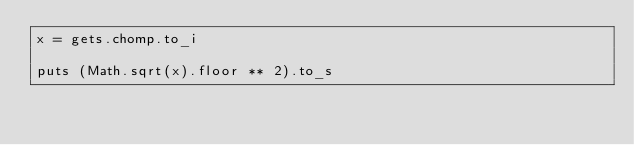Convert code to text. <code><loc_0><loc_0><loc_500><loc_500><_Ruby_>x = gets.chomp.to_i

puts (Math.sqrt(x).floor ** 2).to_s</code> 